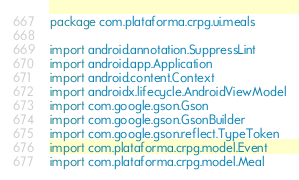Convert code to text. <code><loc_0><loc_0><loc_500><loc_500><_Kotlin_>package com.plataforma.crpg.ui.meals

import android.annotation.SuppressLint
import android.app.Application
import android.content.Context
import androidx.lifecycle.AndroidViewModel
import com.google.gson.Gson
import com.google.gson.GsonBuilder
import com.google.gson.reflect.TypeToken
import com.plataforma.crpg.model.Event
import com.plataforma.crpg.model.Meal</code> 